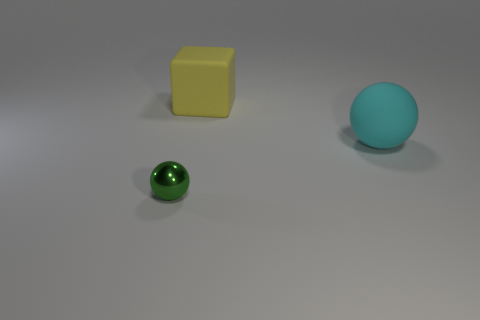Is there anything else that has the same size as the metal object?
Your answer should be very brief. No. Is there another tiny metallic object of the same shape as the tiny green metallic thing?
Offer a terse response. No. Are there fewer cubes than green rubber objects?
Make the answer very short. No. There is a sphere right of the big yellow rubber thing; what color is it?
Ensure brevity in your answer.  Cyan. The thing that is in front of the sphere that is behind the green metal thing is what shape?
Your answer should be compact. Sphere. Is the small green object made of the same material as the sphere that is to the right of the tiny green shiny ball?
Offer a very short reply. No. How many red metallic cubes are the same size as the yellow object?
Provide a short and direct response. 0. Is the number of large balls on the right side of the big ball less than the number of large cyan matte balls?
Your response must be concise. Yes. There is a block; how many cyan rubber objects are in front of it?
Ensure brevity in your answer.  1. How big is the thing that is in front of the sphere to the right of the sphere that is in front of the big cyan matte sphere?
Your answer should be compact. Small. 